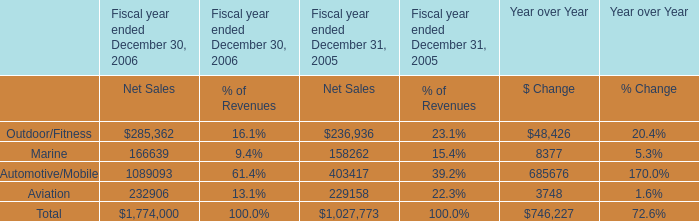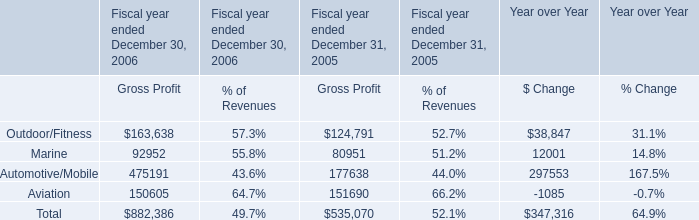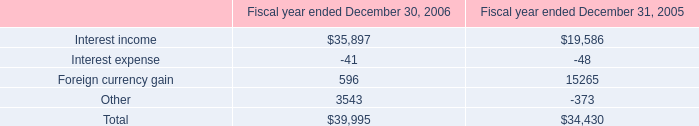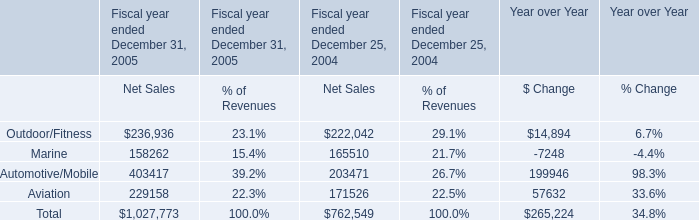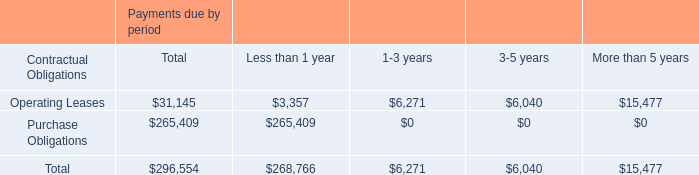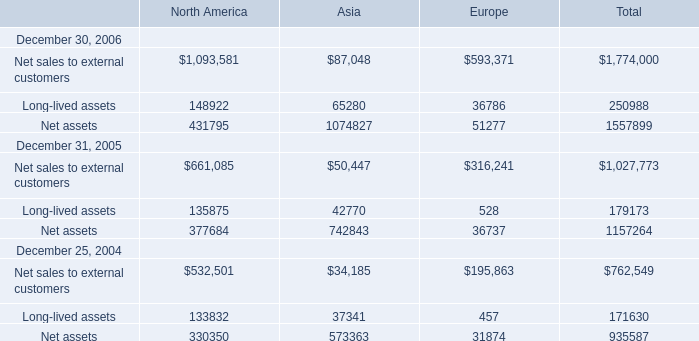As As the chart 5 shows,what is the sum of the Net assets for Europe in the range of 40 and 60? 
Answer: 51277. 